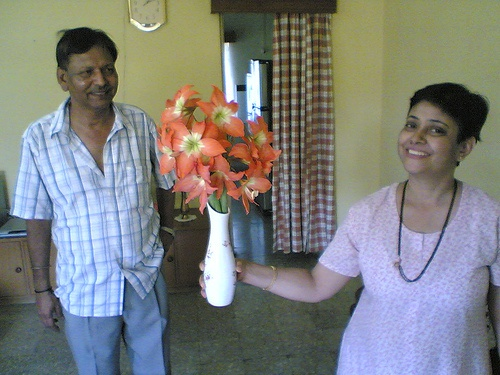Describe the objects in this image and their specific colors. I can see people in darkgray, lightblue, gray, and black tones, people in darkgray, lavender, gray, and black tones, vase in darkgray, white, and lavender tones, refrigerator in darkgray, black, white, gray, and darkgreen tones, and clock in darkgray, tan, beige, and khaki tones in this image. 